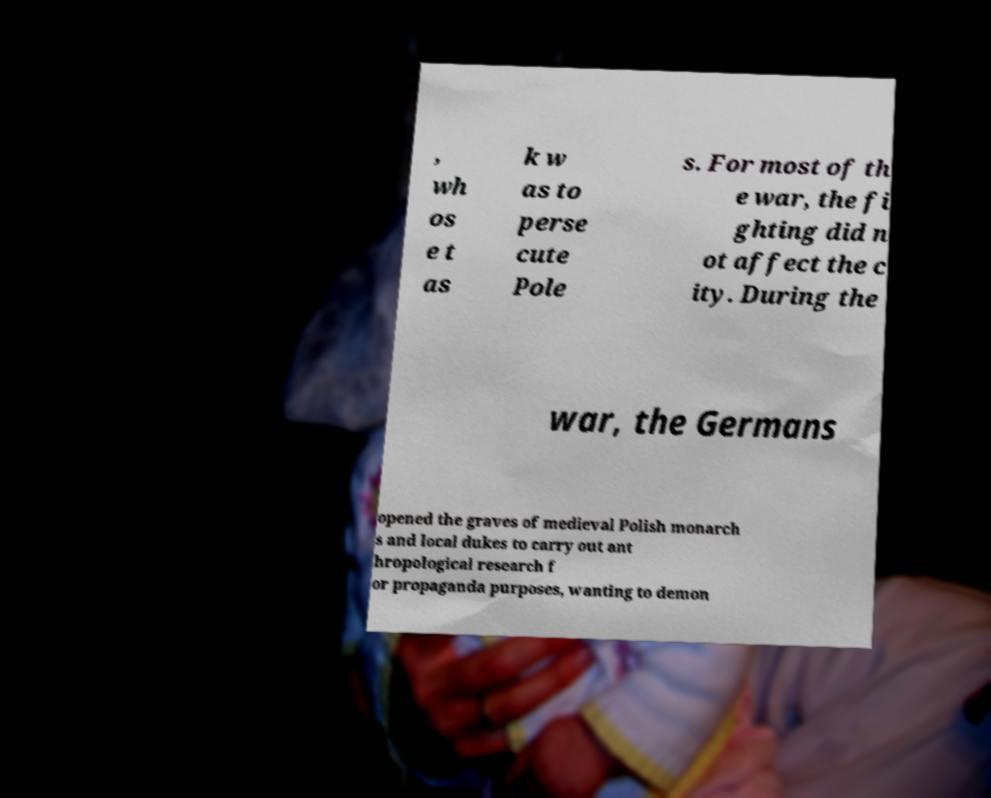For documentation purposes, I need the text within this image transcribed. Could you provide that? , wh os e t as k w as to perse cute Pole s. For most of th e war, the fi ghting did n ot affect the c ity. During the war, the Germans opened the graves of medieval Polish monarch s and local dukes to carry out ant hropological research f or propaganda purposes, wanting to demon 